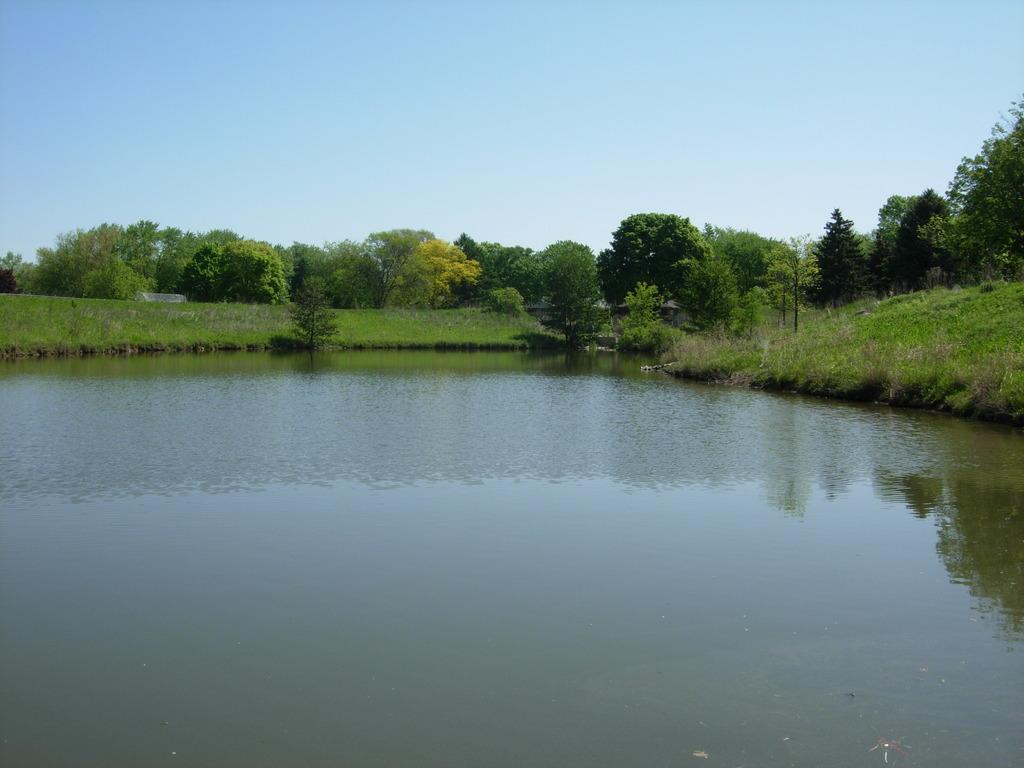What is one of the natural elements present in the image? There is water in the image. What type of vegetation can be seen in the image? There is grass, plants, and trees in the image. What can be seen in the background of the image? The sky is visible in the background of the image. What type of berry is growing on the shoes in the image? There are no shoes or berries present in the image. 